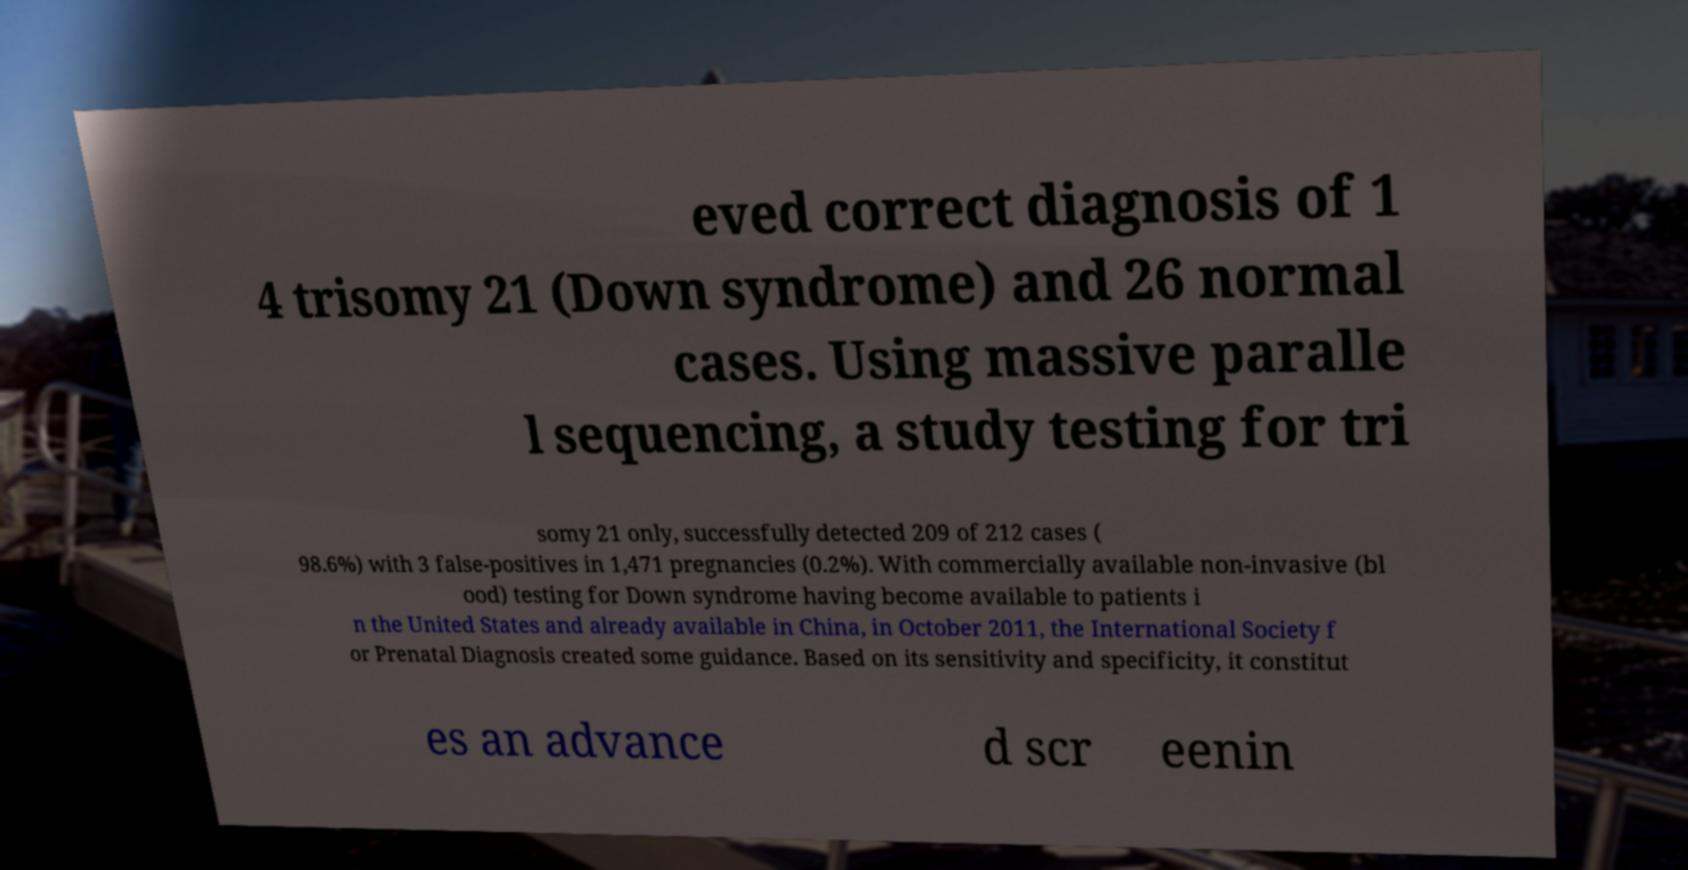There's text embedded in this image that I need extracted. Can you transcribe it verbatim? eved correct diagnosis of 1 4 trisomy 21 (Down syndrome) and 26 normal cases. Using massive paralle l sequencing, a study testing for tri somy 21 only, successfully detected 209 of 212 cases ( 98.6%) with 3 false-positives in 1,471 pregnancies (0.2%). With commercially available non-invasive (bl ood) testing for Down syndrome having become available to patients i n the United States and already available in China, in October 2011, the International Society f or Prenatal Diagnosis created some guidance. Based on its sensitivity and specificity, it constitut es an advance d scr eenin 